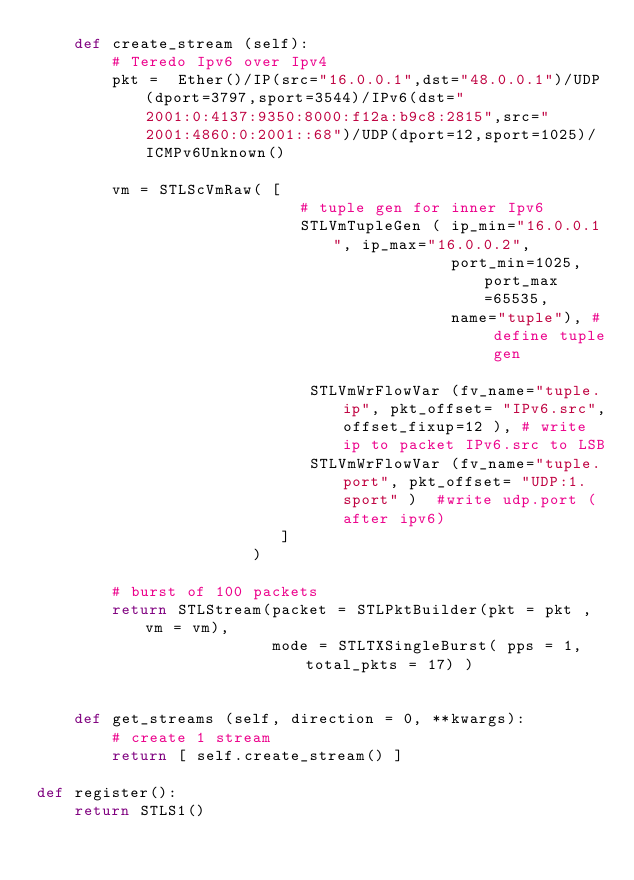<code> <loc_0><loc_0><loc_500><loc_500><_Python_>    def create_stream (self):
        # Teredo Ipv6 over Ipv4 
        pkt =  Ether()/IP(src="16.0.0.1",dst="48.0.0.1")/UDP(dport=3797,sport=3544)/IPv6(dst="2001:0:4137:9350:8000:f12a:b9c8:2815",src="2001:4860:0:2001::68")/UDP(dport=12,sport=1025)/ICMPv6Unknown()

        vm = STLScVmRaw( [ 
                            # tuple gen for inner Ipv6 
                            STLVmTupleGen ( ip_min="16.0.0.1", ip_max="16.0.0.2", 
                                            port_min=1025, port_max=65535,
                                            name="tuple"), # define tuple gen 

                             STLVmWrFlowVar (fv_name="tuple.ip", pkt_offset= "IPv6.src",offset_fixup=12 ), # write ip to packet IPv6.src to LSB
                             STLVmWrFlowVar (fv_name="tuple.port", pkt_offset= "UDP:1.sport" )  #write udp.port (after ipv6)
                          ]
                       )

        # burst of 100 packets
        return STLStream(packet = STLPktBuilder(pkt = pkt ,vm = vm),
                         mode = STLTXSingleBurst( pps = 1, total_pkts = 17) )


    def get_streams (self, direction = 0, **kwargs):
        # create 1 stream 
        return [ self.create_stream() ]

def register():
    return STLS1()




</code> 